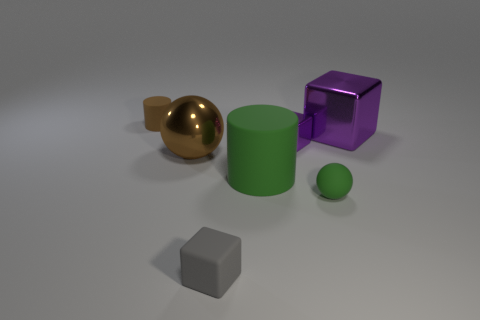What number of cyan things are matte cubes or cylinders?
Give a very brief answer. 0. How many things are in front of the large brown metal ball and behind the tiny green ball?
Your response must be concise. 1. What material is the big object behind the sphere to the left of the cube in front of the large green rubber cylinder made of?
Your answer should be very brief. Metal. How many big blue things have the same material as the gray object?
Your answer should be compact. 0. There is a large metallic thing that is the same color as the tiny rubber cylinder; what shape is it?
Ensure brevity in your answer.  Sphere. The purple thing that is the same size as the gray matte object is what shape?
Give a very brief answer. Cube. What is the material of the small cylinder that is the same color as the large ball?
Make the answer very short. Rubber. Are there any brown cylinders behind the gray thing?
Provide a short and direct response. Yes. Is there a rubber object that has the same shape as the brown shiny thing?
Provide a short and direct response. Yes. Does the big metallic object on the left side of the big purple cube have the same shape as the big shiny object to the right of the big green thing?
Provide a succinct answer. No. 